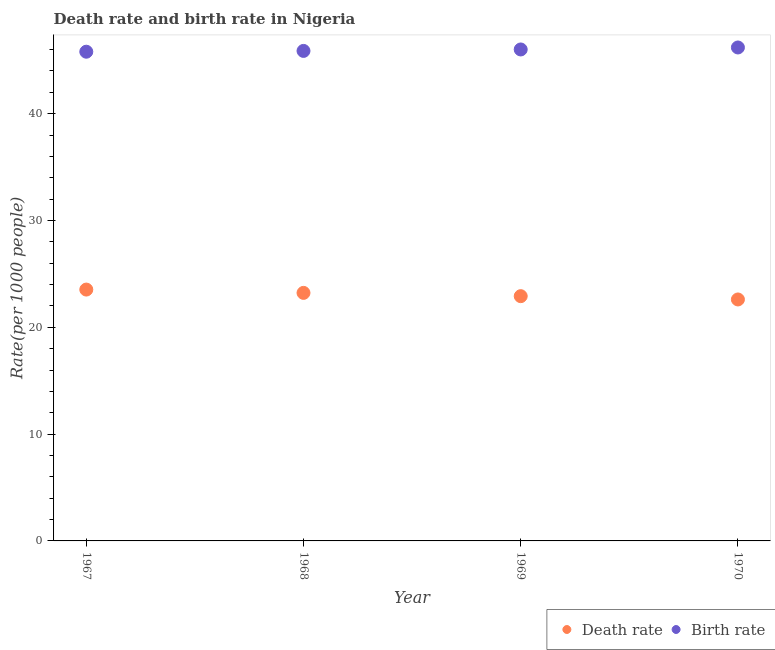How many different coloured dotlines are there?
Make the answer very short. 2. Is the number of dotlines equal to the number of legend labels?
Offer a very short reply. Yes. What is the death rate in 1969?
Keep it short and to the point. 22.92. Across all years, what is the maximum birth rate?
Your answer should be compact. 46.2. Across all years, what is the minimum birth rate?
Your response must be concise. 45.8. In which year was the death rate maximum?
Provide a succinct answer. 1967. What is the total birth rate in the graph?
Give a very brief answer. 183.89. What is the difference between the death rate in 1967 and that in 1970?
Your answer should be compact. 0.93. What is the difference between the death rate in 1968 and the birth rate in 1967?
Offer a very short reply. -22.58. What is the average death rate per year?
Make the answer very short. 23.07. In the year 1968, what is the difference between the death rate and birth rate?
Your answer should be compact. -22.65. What is the ratio of the birth rate in 1967 to that in 1970?
Make the answer very short. 0.99. Is the difference between the death rate in 1967 and 1968 greater than the difference between the birth rate in 1967 and 1968?
Provide a succinct answer. Yes. What is the difference between the highest and the second highest death rate?
Your answer should be very brief. 0.31. What is the difference between the highest and the lowest birth rate?
Ensure brevity in your answer.  0.4. In how many years, is the birth rate greater than the average birth rate taken over all years?
Provide a short and direct response. 2. Is the sum of the death rate in 1969 and 1970 greater than the maximum birth rate across all years?
Provide a succinct answer. No. Is the birth rate strictly greater than the death rate over the years?
Keep it short and to the point. Yes. How many dotlines are there?
Your answer should be compact. 2. How many years are there in the graph?
Provide a succinct answer. 4. Are the values on the major ticks of Y-axis written in scientific E-notation?
Your answer should be compact. No. Where does the legend appear in the graph?
Ensure brevity in your answer.  Bottom right. How are the legend labels stacked?
Give a very brief answer. Horizontal. What is the title of the graph?
Your answer should be very brief. Death rate and birth rate in Nigeria. Does "Malaria" appear as one of the legend labels in the graph?
Your response must be concise. No. What is the label or title of the Y-axis?
Offer a very short reply. Rate(per 1000 people). What is the Rate(per 1000 people) in Death rate in 1967?
Keep it short and to the point. 23.53. What is the Rate(per 1000 people) in Birth rate in 1967?
Provide a succinct answer. 45.8. What is the Rate(per 1000 people) in Death rate in 1968?
Ensure brevity in your answer.  23.22. What is the Rate(per 1000 people) of Birth rate in 1968?
Your response must be concise. 45.88. What is the Rate(per 1000 people) in Death rate in 1969?
Provide a succinct answer. 22.92. What is the Rate(per 1000 people) in Birth rate in 1969?
Give a very brief answer. 46.01. What is the Rate(per 1000 people) of Death rate in 1970?
Offer a very short reply. 22.61. What is the Rate(per 1000 people) in Birth rate in 1970?
Offer a terse response. 46.2. Across all years, what is the maximum Rate(per 1000 people) of Death rate?
Your answer should be compact. 23.53. Across all years, what is the maximum Rate(per 1000 people) in Birth rate?
Provide a short and direct response. 46.2. Across all years, what is the minimum Rate(per 1000 people) in Death rate?
Your answer should be compact. 22.61. Across all years, what is the minimum Rate(per 1000 people) in Birth rate?
Your answer should be compact. 45.8. What is the total Rate(per 1000 people) of Death rate in the graph?
Provide a succinct answer. 92.28. What is the total Rate(per 1000 people) of Birth rate in the graph?
Your response must be concise. 183.9. What is the difference between the Rate(per 1000 people) of Death rate in 1967 and that in 1968?
Your answer should be very brief. 0.31. What is the difference between the Rate(per 1000 people) of Birth rate in 1967 and that in 1968?
Give a very brief answer. -0.07. What is the difference between the Rate(per 1000 people) of Death rate in 1967 and that in 1969?
Offer a very short reply. 0.62. What is the difference between the Rate(per 1000 people) in Birth rate in 1967 and that in 1969?
Ensure brevity in your answer.  -0.21. What is the difference between the Rate(per 1000 people) in Death rate in 1967 and that in 1970?
Your answer should be compact. 0.93. What is the difference between the Rate(per 1000 people) in Birth rate in 1967 and that in 1970?
Give a very brief answer. -0.4. What is the difference between the Rate(per 1000 people) of Death rate in 1968 and that in 1969?
Your response must be concise. 0.31. What is the difference between the Rate(per 1000 people) in Birth rate in 1968 and that in 1969?
Offer a terse response. -0.14. What is the difference between the Rate(per 1000 people) in Death rate in 1968 and that in 1970?
Ensure brevity in your answer.  0.62. What is the difference between the Rate(per 1000 people) in Birth rate in 1968 and that in 1970?
Make the answer very short. -0.32. What is the difference between the Rate(per 1000 people) in Death rate in 1969 and that in 1970?
Offer a very short reply. 0.31. What is the difference between the Rate(per 1000 people) of Birth rate in 1969 and that in 1970?
Offer a very short reply. -0.19. What is the difference between the Rate(per 1000 people) in Death rate in 1967 and the Rate(per 1000 people) in Birth rate in 1968?
Keep it short and to the point. -22.34. What is the difference between the Rate(per 1000 people) of Death rate in 1967 and the Rate(per 1000 people) of Birth rate in 1969?
Your answer should be compact. -22.48. What is the difference between the Rate(per 1000 people) in Death rate in 1967 and the Rate(per 1000 people) in Birth rate in 1970?
Keep it short and to the point. -22.67. What is the difference between the Rate(per 1000 people) of Death rate in 1968 and the Rate(per 1000 people) of Birth rate in 1969?
Your answer should be compact. -22.79. What is the difference between the Rate(per 1000 people) of Death rate in 1968 and the Rate(per 1000 people) of Birth rate in 1970?
Keep it short and to the point. -22.98. What is the difference between the Rate(per 1000 people) in Death rate in 1969 and the Rate(per 1000 people) in Birth rate in 1970?
Ensure brevity in your answer.  -23.28. What is the average Rate(per 1000 people) of Death rate per year?
Offer a very short reply. 23.07. What is the average Rate(per 1000 people) in Birth rate per year?
Your answer should be very brief. 45.97. In the year 1967, what is the difference between the Rate(per 1000 people) in Death rate and Rate(per 1000 people) in Birth rate?
Offer a terse response. -22.27. In the year 1968, what is the difference between the Rate(per 1000 people) of Death rate and Rate(per 1000 people) of Birth rate?
Your answer should be compact. -22.66. In the year 1969, what is the difference between the Rate(per 1000 people) in Death rate and Rate(per 1000 people) in Birth rate?
Offer a terse response. -23.1. In the year 1970, what is the difference between the Rate(per 1000 people) in Death rate and Rate(per 1000 people) in Birth rate?
Your answer should be compact. -23.59. What is the ratio of the Rate(per 1000 people) in Death rate in 1967 to that in 1968?
Keep it short and to the point. 1.01. What is the ratio of the Rate(per 1000 people) in Birth rate in 1967 to that in 1968?
Provide a succinct answer. 1. What is the ratio of the Rate(per 1000 people) in Death rate in 1967 to that in 1969?
Offer a terse response. 1.03. What is the ratio of the Rate(per 1000 people) in Death rate in 1967 to that in 1970?
Offer a very short reply. 1.04. What is the ratio of the Rate(per 1000 people) of Birth rate in 1967 to that in 1970?
Offer a terse response. 0.99. What is the ratio of the Rate(per 1000 people) in Death rate in 1968 to that in 1969?
Provide a succinct answer. 1.01. What is the ratio of the Rate(per 1000 people) of Death rate in 1968 to that in 1970?
Your answer should be compact. 1.03. What is the ratio of the Rate(per 1000 people) in Death rate in 1969 to that in 1970?
Your response must be concise. 1.01. What is the ratio of the Rate(per 1000 people) in Birth rate in 1969 to that in 1970?
Your answer should be very brief. 1. What is the difference between the highest and the second highest Rate(per 1000 people) in Death rate?
Make the answer very short. 0.31. What is the difference between the highest and the second highest Rate(per 1000 people) in Birth rate?
Provide a succinct answer. 0.19. What is the difference between the highest and the lowest Rate(per 1000 people) in Death rate?
Keep it short and to the point. 0.93. What is the difference between the highest and the lowest Rate(per 1000 people) in Birth rate?
Make the answer very short. 0.4. 